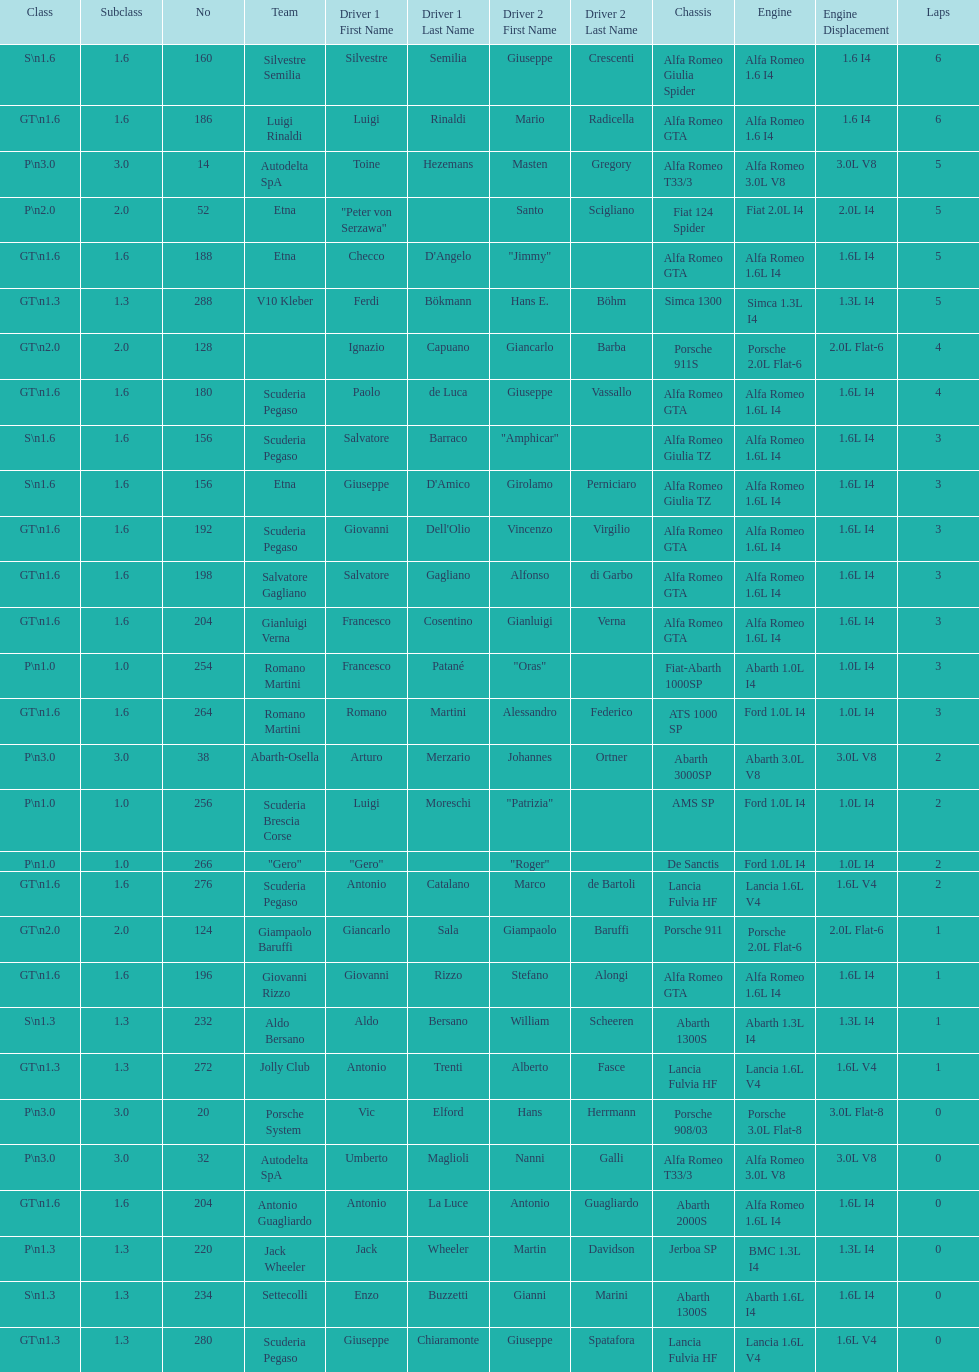Can you parse all the data within this table? {'header': ['Class', 'Subclass', 'No', 'Team', 'Driver 1 First Name', 'Driver 1 Last Name', 'Driver 2 First Name', 'Driver 2 Last Name', 'Chassis', 'Engine', 'Engine Displacement', 'Laps'], 'rows': [['S\\n1.6', '1.6', '160', 'Silvestre Semilia', 'Silvestre', 'Semilia', 'Giuseppe', 'Crescenti', 'Alfa Romeo Giulia Spider', 'Alfa Romeo 1.6 I4', '1.6 I4', '6'], ['GT\\n1.6', '1.6', '186', 'Luigi Rinaldi', 'Luigi', 'Rinaldi', 'Mario', 'Radicella', 'Alfa Romeo GTA', 'Alfa Romeo 1.6 I4', '1.6 I4', '6'], ['P\\n3.0', '3.0', '14', 'Autodelta SpA', 'Toine', 'Hezemans', 'Masten', 'Gregory', 'Alfa Romeo T33/3', 'Alfa Romeo 3.0L V8', '3.0L V8', '5'], ['P\\n2.0', '2.0', '52', 'Etna', '"Peter von Serzawa"', '', 'Santo', 'Scigliano', 'Fiat 124 Spider', 'Fiat 2.0L I4', '2.0L I4', '5'], ['GT\\n1.6', '1.6', '188', 'Etna', 'Checco', "D'Angelo", '"Jimmy"', '', 'Alfa Romeo GTA', 'Alfa Romeo 1.6L I4', '1.6L I4', '5'], ['GT\\n1.3', '1.3', '288', 'V10 Kleber', 'Ferdi', 'Bökmann', 'Hans E.', 'Böhm', 'Simca 1300', 'Simca 1.3L I4', '1.3L I4', '5'], ['GT\\n2.0', '2.0', '128', '', 'Ignazio', 'Capuano', 'Giancarlo', 'Barba', 'Porsche 911S', 'Porsche 2.0L Flat-6', '2.0L Flat-6', '4'], ['GT\\n1.6', '1.6', '180', 'Scuderia Pegaso', 'Paolo', 'de Luca', 'Giuseppe', 'Vassallo', 'Alfa Romeo GTA', 'Alfa Romeo 1.6L I4', '1.6L I4', '4'], ['S\\n1.6', '1.6', '156', 'Scuderia Pegaso', 'Salvatore', 'Barraco', '"Amphicar"', '', 'Alfa Romeo Giulia TZ', 'Alfa Romeo 1.6L I4', '1.6L I4', '3'], ['S\\n1.6', '1.6', '156', 'Etna', 'Giuseppe', "D'Amico", 'Girolamo', 'Perniciaro', 'Alfa Romeo Giulia TZ', 'Alfa Romeo 1.6L I4', '1.6L I4', '3'], ['GT\\n1.6', '1.6', '192', 'Scuderia Pegaso', 'Giovanni', "Dell'Olio", 'Vincenzo', 'Virgilio', 'Alfa Romeo GTA', 'Alfa Romeo 1.6L I4', '1.6L I4', '3'], ['GT\\n1.6', '1.6', '198', 'Salvatore Gagliano', 'Salvatore', 'Gagliano', 'Alfonso', 'di Garbo', 'Alfa Romeo GTA', 'Alfa Romeo 1.6L I4', '1.6L I4', '3'], ['GT\\n1.6', '1.6', '204', 'Gianluigi Verna', 'Francesco', 'Cosentino', 'Gianluigi', 'Verna', 'Alfa Romeo GTA', 'Alfa Romeo 1.6L I4', '1.6L I4', '3'], ['P\\n1.0', '1.0', '254', 'Romano Martini', 'Francesco', 'Patané', '"Oras"', '', 'Fiat-Abarth 1000SP', 'Abarth 1.0L I4', '1.0L I4', '3'], ['GT\\n1.6', '1.6', '264', 'Romano Martini', 'Romano', 'Martini', 'Alessandro', 'Federico', 'ATS 1000 SP', 'Ford 1.0L I4', '1.0L I4', '3'], ['P\\n3.0', '3.0', '38', 'Abarth-Osella', 'Arturo', 'Merzario', 'Johannes', 'Ortner', 'Abarth 3000SP', 'Abarth 3.0L V8', '3.0L V8', '2'], ['P\\n1.0', '1.0', '256', 'Scuderia Brescia Corse', 'Luigi', 'Moreschi', '"Patrizia"', '', 'AMS SP', 'Ford 1.0L I4', '1.0L I4', '2'], ['P\\n1.0', '1.0', '266', '"Gero"', '"Gero"', '', '"Roger"', '', 'De Sanctis', 'Ford 1.0L I4', '1.0L I4', '2'], ['GT\\n1.6', '1.6', '276', 'Scuderia Pegaso', 'Antonio', 'Catalano', 'Marco', 'de Bartoli', 'Lancia Fulvia HF', 'Lancia 1.6L V4', '1.6L V4', '2'], ['GT\\n2.0', '2.0', '124', 'Giampaolo Baruffi', 'Giancarlo', 'Sala', 'Giampaolo', 'Baruffi', 'Porsche 911', 'Porsche 2.0L Flat-6', '2.0L Flat-6', '1'], ['GT\\n1.6', '1.6', '196', 'Giovanni Rizzo', 'Giovanni', 'Rizzo', 'Stefano', 'Alongi', 'Alfa Romeo GTA', 'Alfa Romeo 1.6L I4', '1.6L I4', '1'], ['S\\n1.3', '1.3', '232', 'Aldo Bersano', 'Aldo', 'Bersano', 'William', 'Scheeren', 'Abarth 1300S', 'Abarth 1.3L I4', '1.3L I4', '1'], ['GT\\n1.3', '1.3', '272', 'Jolly Club', 'Antonio', 'Trenti', 'Alberto', 'Fasce', 'Lancia Fulvia HF', 'Lancia 1.6L V4', '1.6L V4', '1'], ['P\\n3.0', '3.0', '20', 'Porsche System', 'Vic', 'Elford', 'Hans', 'Herrmann', 'Porsche 908/03', 'Porsche 3.0L Flat-8', '3.0L Flat-8', '0'], ['P\\n3.0', '3.0', '32', 'Autodelta SpA', 'Umberto', 'Maglioli', 'Nanni', 'Galli', 'Alfa Romeo T33/3', 'Alfa Romeo 3.0L V8', '3.0L V8', '0'], ['GT\\n1.6', '1.6', '204', 'Antonio Guagliardo', 'Antonio', 'La Luce', 'Antonio', 'Guagliardo', 'Abarth 2000S', 'Alfa Romeo 1.6L I4', '1.6L I4', '0'], ['P\\n1.3', '1.3', '220', 'Jack Wheeler', 'Jack', 'Wheeler', 'Martin', 'Davidson', 'Jerboa SP', 'BMC 1.3L I4', '1.3L I4', '0'], ['S\\n1.3', '1.3', '234', 'Settecolli', 'Enzo', 'Buzzetti', 'Gianni', 'Marini', 'Abarth 1300S', 'Abarth 1.6L I4', '1.6L I4', '0'], ['GT\\n1.3', '1.3', '280', 'Scuderia Pegaso', 'Giuseppe', 'Chiaramonte', 'Giuseppe', 'Spatafora', 'Lancia Fulvia HF', 'Lancia 1.6L V4', '1.6L V4', '0']]} How many laps does v10 kleber have? 5. 